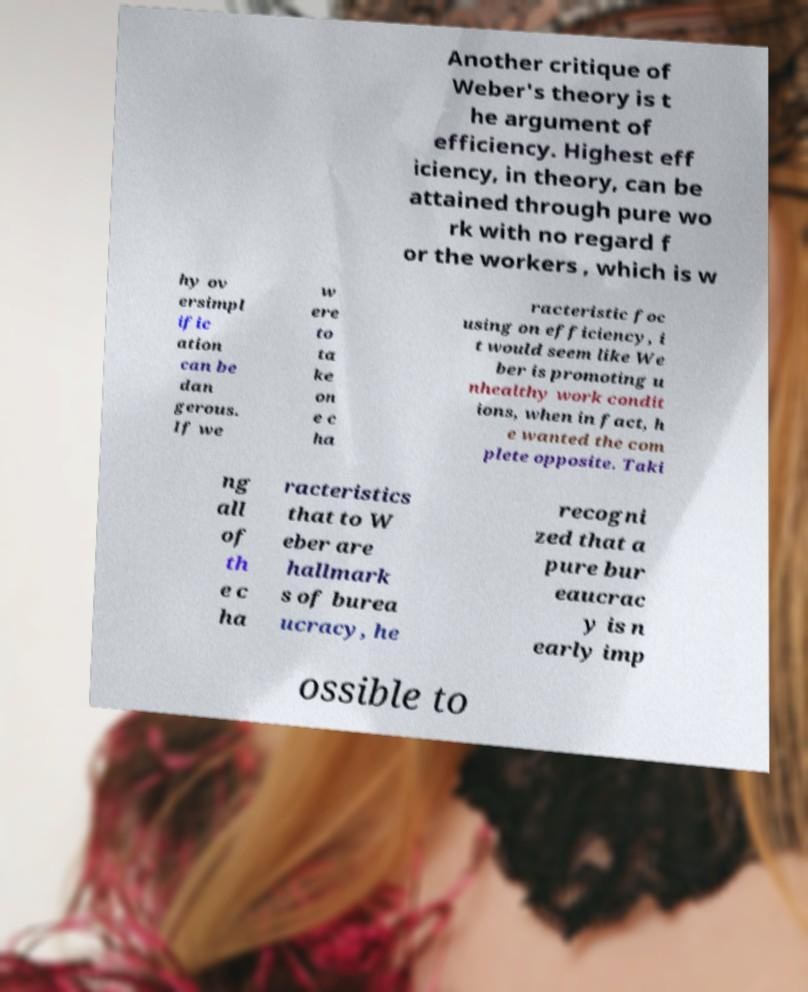I need the written content from this picture converted into text. Can you do that? Another critique of Weber's theory is t he argument of efficiency. Highest eff iciency, in theory, can be attained through pure wo rk with no regard f or the workers , which is w hy ov ersimpl ific ation can be dan gerous. If we w ere to ta ke on e c ha racteristic foc using on efficiency, i t would seem like We ber is promoting u nhealthy work condit ions, when in fact, h e wanted the com plete opposite. Taki ng all of th e c ha racteristics that to W eber are hallmark s of burea ucracy, he recogni zed that a pure bur eaucrac y is n early imp ossible to 